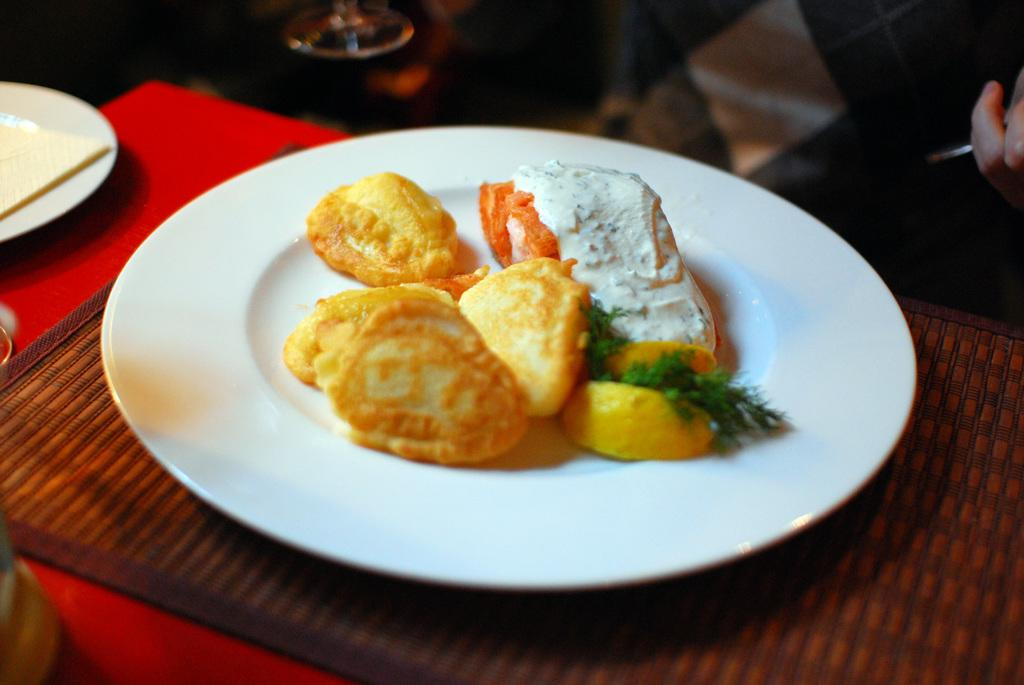What is on the plate in the image? There are food items on a plate in the image. What else can be seen on the table besides the plate? There are other objects on the table in the image. Can you describe the presence of a person in the image? The hand of a person is visible on the right side of the image. What type of shoe is the person wearing in the image? There is no shoe visible in the image; only the hand of a person is visible on the right side. What pets can be seen in the image? There are no pets present in the image. 